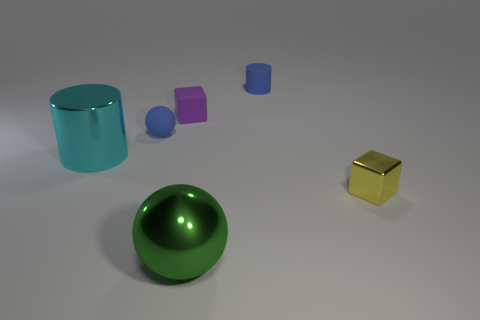Subtract all purple cubes. How many cubes are left? 1 Add 4 cubes. How many objects exist? 10 Subtract 2 cubes. How many cubes are left? 0 Subtract all cylinders. How many objects are left? 4 Subtract all blue cylinders. Subtract all green balls. How many cylinders are left? 1 Subtract all blue cubes. How many brown balls are left? 0 Subtract all large cyan cylinders. Subtract all blue cylinders. How many objects are left? 4 Add 4 yellow metal objects. How many yellow metal objects are left? 5 Add 5 tiny things. How many tiny things exist? 9 Subtract 0 brown spheres. How many objects are left? 6 